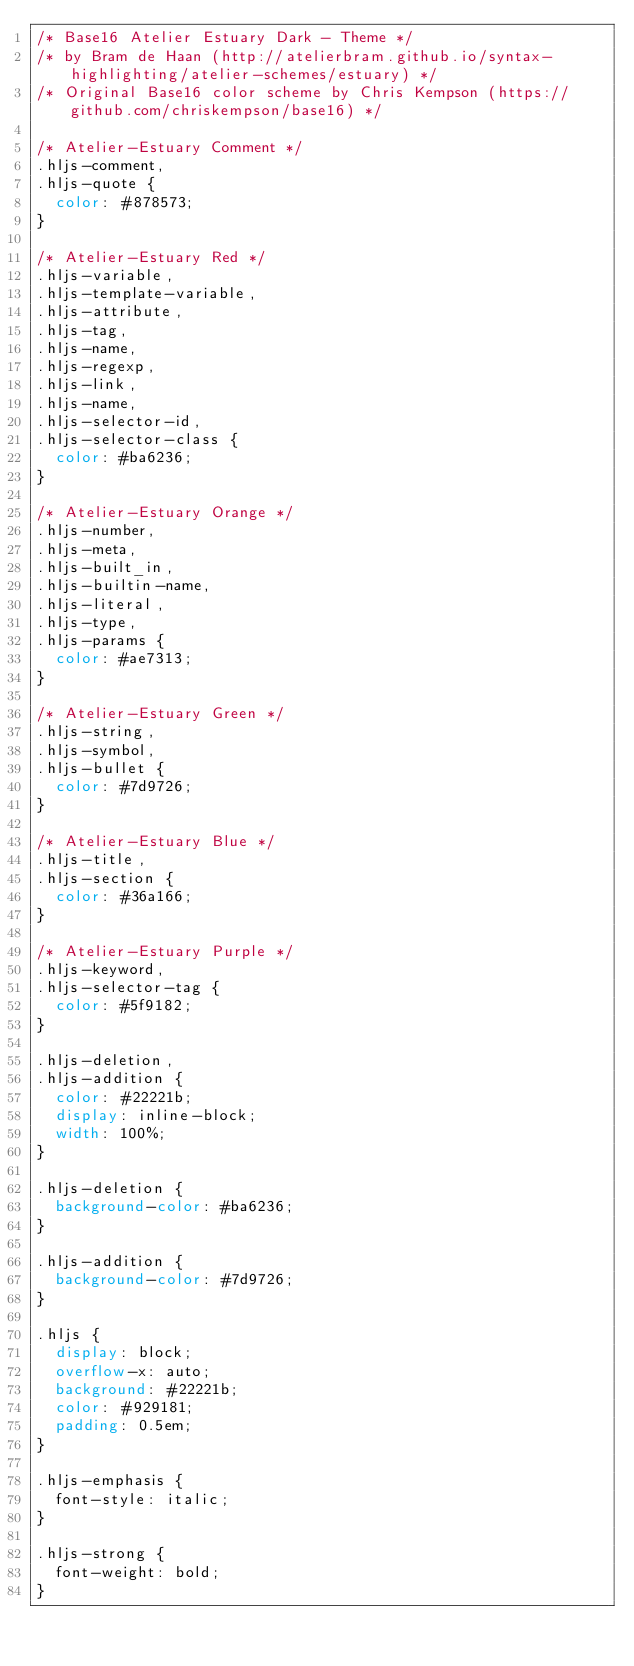<code> <loc_0><loc_0><loc_500><loc_500><_CSS_>/* Base16 Atelier Estuary Dark - Theme */
/* by Bram de Haan (http://atelierbram.github.io/syntax-highlighting/atelier-schemes/estuary) */
/* Original Base16 color scheme by Chris Kempson (https://github.com/chriskempson/base16) */

/* Atelier-Estuary Comment */
.hljs-comment,
.hljs-quote {
  color: #878573;
}

/* Atelier-Estuary Red */
.hljs-variable,
.hljs-template-variable,
.hljs-attribute,
.hljs-tag,
.hljs-name,
.hljs-regexp,
.hljs-link,
.hljs-name,
.hljs-selector-id,
.hljs-selector-class {
  color: #ba6236;
}

/* Atelier-Estuary Orange */
.hljs-number,
.hljs-meta,
.hljs-built_in,
.hljs-builtin-name,
.hljs-literal,
.hljs-type,
.hljs-params {
  color: #ae7313;
}

/* Atelier-Estuary Green */
.hljs-string,
.hljs-symbol,
.hljs-bullet {
  color: #7d9726;
}

/* Atelier-Estuary Blue */
.hljs-title,
.hljs-section {
  color: #36a166;
}

/* Atelier-Estuary Purple */
.hljs-keyword,
.hljs-selector-tag {
  color: #5f9182;
}

.hljs-deletion,
.hljs-addition {
  color: #22221b;
  display: inline-block;
  width: 100%;
}

.hljs-deletion {
  background-color: #ba6236;
}

.hljs-addition {
  background-color: #7d9726;
}

.hljs {
  display: block;
  overflow-x: auto;
  background: #22221b;
  color: #929181;
  padding: 0.5em;
}

.hljs-emphasis {
  font-style: italic;
}

.hljs-strong {
  font-weight: bold;
}
</code> 